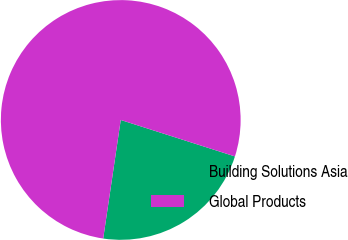Convert chart. <chart><loc_0><loc_0><loc_500><loc_500><pie_chart><fcel>Building Solutions Asia<fcel>Global Products<nl><fcel>22.42%<fcel>77.58%<nl></chart> 